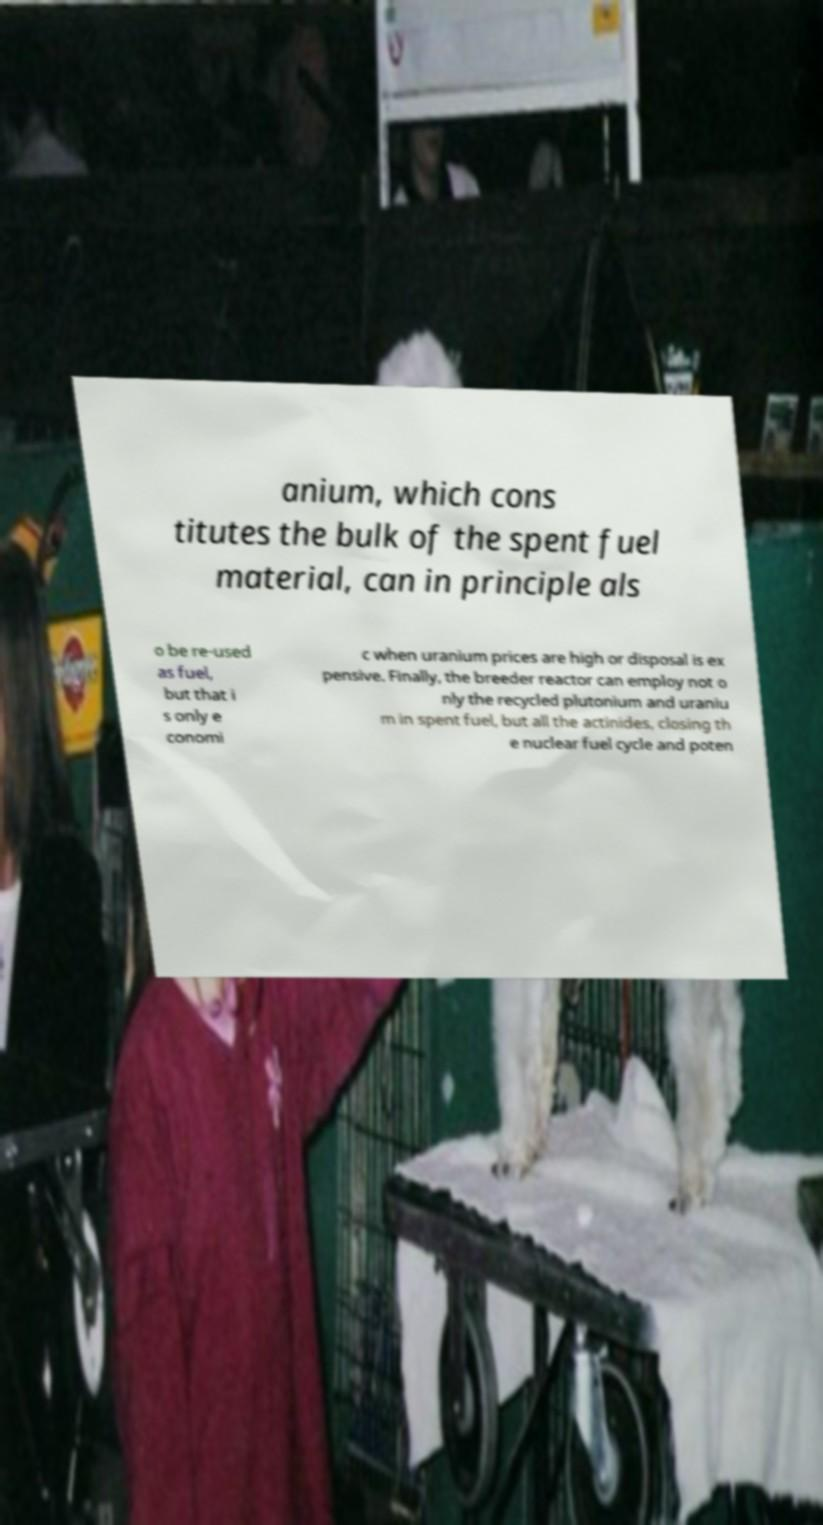Can you accurately transcribe the text from the provided image for me? anium, which cons titutes the bulk of the spent fuel material, can in principle als o be re-used as fuel, but that i s only e conomi c when uranium prices are high or disposal is ex pensive. Finally, the breeder reactor can employ not o nly the recycled plutonium and uraniu m in spent fuel, but all the actinides, closing th e nuclear fuel cycle and poten 